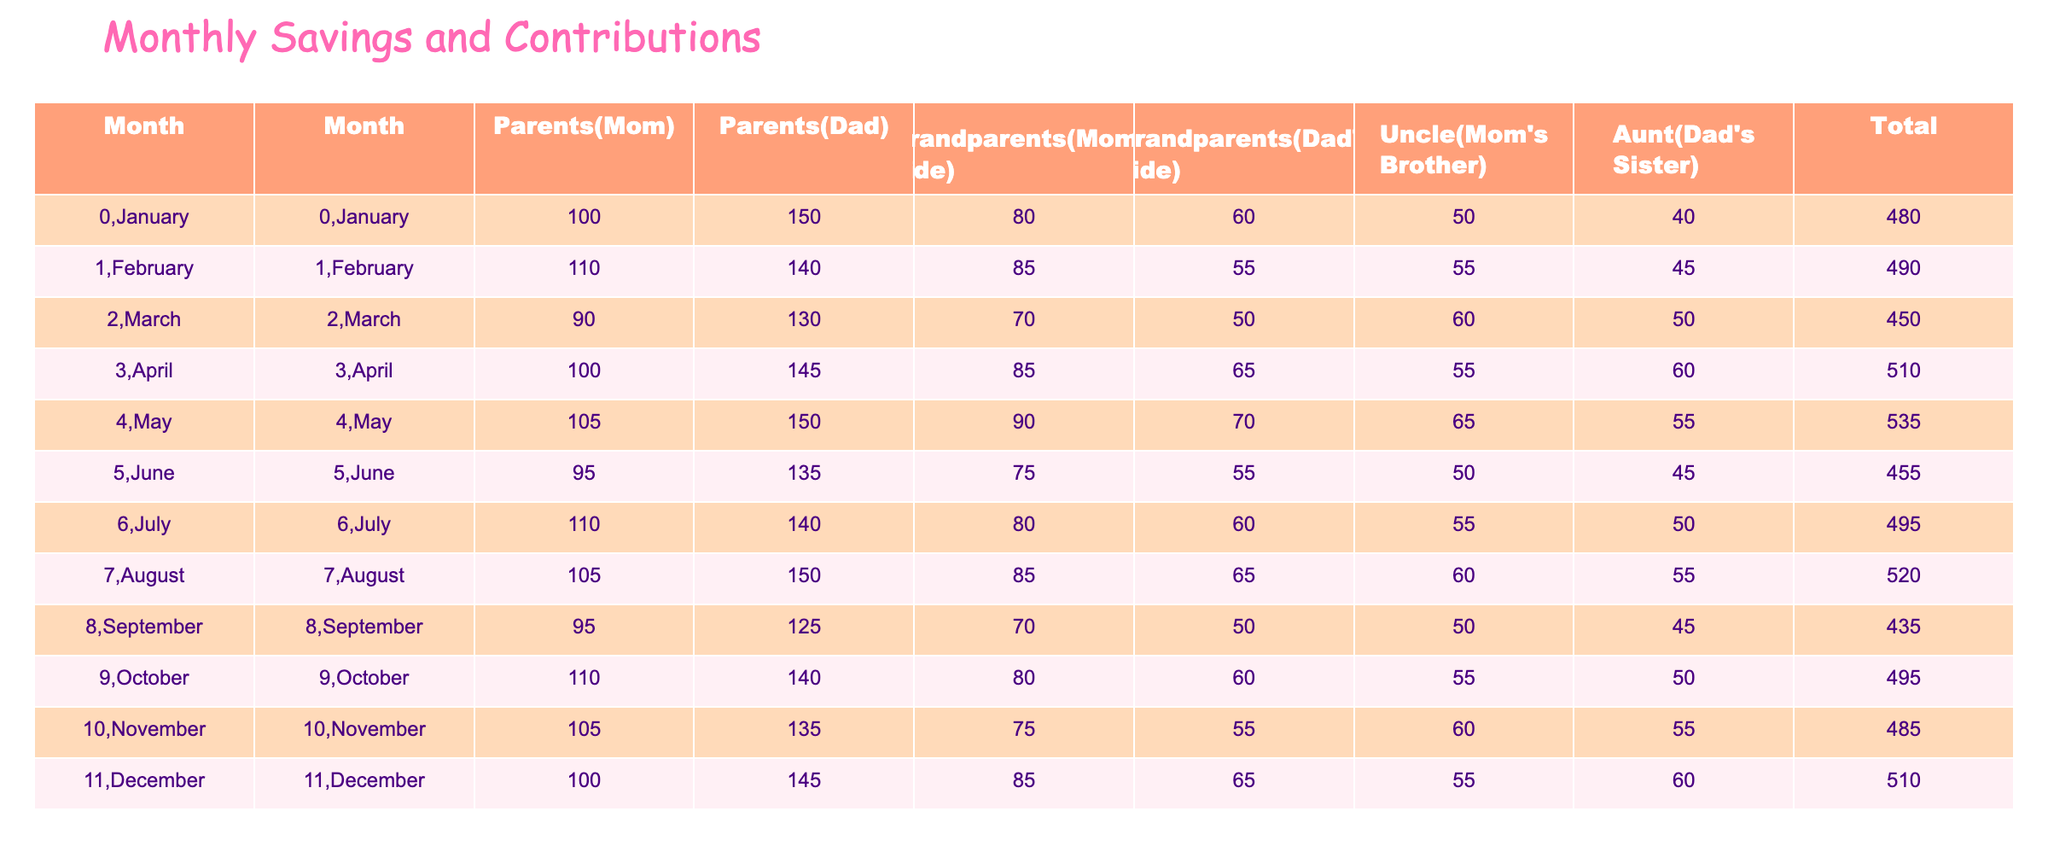What is the total contribution in January? To find the total contribution for January, add the values from all contributors: 100 (Mom) + 150 (Dad) + 80 (Mom's Side Grandparents) + 60 (Dad's Side Grandparents) + 50 (Uncle) + 40 (Aunt) = 480.
Answer: 480 Which month had the highest contribution from Dad? Looking through the Dad's contributions for each month, the highest value is 150, which occurs in both January and May.
Answer: January and May What is the average contribution from Mom over the year? To find the average contribution from Mom, sum all her monthly contributions: 100 + 110 + 90 + 100 + 105 + 95 + 110 + 105 + 95 + 110 + 105 + 100 = 1250. There are 12 months, so the average is 1250 / 12 = 104.17.
Answer: 104.17 Did Grandma (Mom's Side) contribute the same amount in March and November? In March, Grandma (Mom's Side) contributed 70, while in November, the contribution was 75. Since 70 is not equal to 75, the answer is no.
Answer: No What is the combined contribution from all relatives in December? For December, we add the contributions: 100 (Mom) + 145 (Dad) + 85 (Mom's Side Grandparents) + 65 (Dad's Side Grandparents) + 55 (Uncle) + 60 (Aunt) = 510.
Answer: 510 Which month had the least total contribution? We need to calculate the total contributions for each month. Upon doing this, September has the lowest total contribution with a sum of 435.
Answer: September How much more did Uncle (Mom's Brother) contribute in May compared to February? Uncle's contribution in May was 65, and in February, it was 55. The difference is 65 - 55 = 10.
Answer: 10 What percentage of the total contributions in April is from Dad? In April, total contributions are 100 (Mom) + 145 (Dad) + 85 (Mom's Side Grandparents) + 65 (Dad's Side Grandparents) + 55 (Uncle) + 60 (Aunt) = 510. Dad's contribution is 145. To find the percentage: (145 / 510) * 100 = 28.43%.
Answer: 28.43% Which parent contributed the least overall over the year? We need to sum the contributions of both parents. Mom's total is 1250, while Dad's total is 1635. Thus, Mom contributed the least overall.
Answer: Mom 